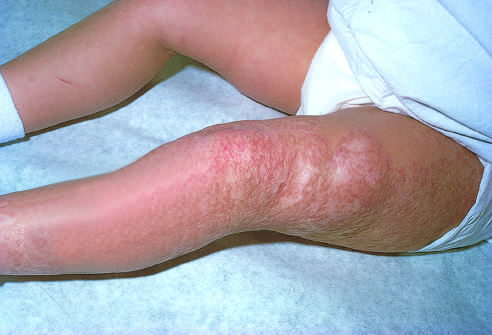had the congenital capillary hemangioma at 2 years of age after the lesion undergone spontaneous regression?
Answer the question using a single word or phrase. Yes 